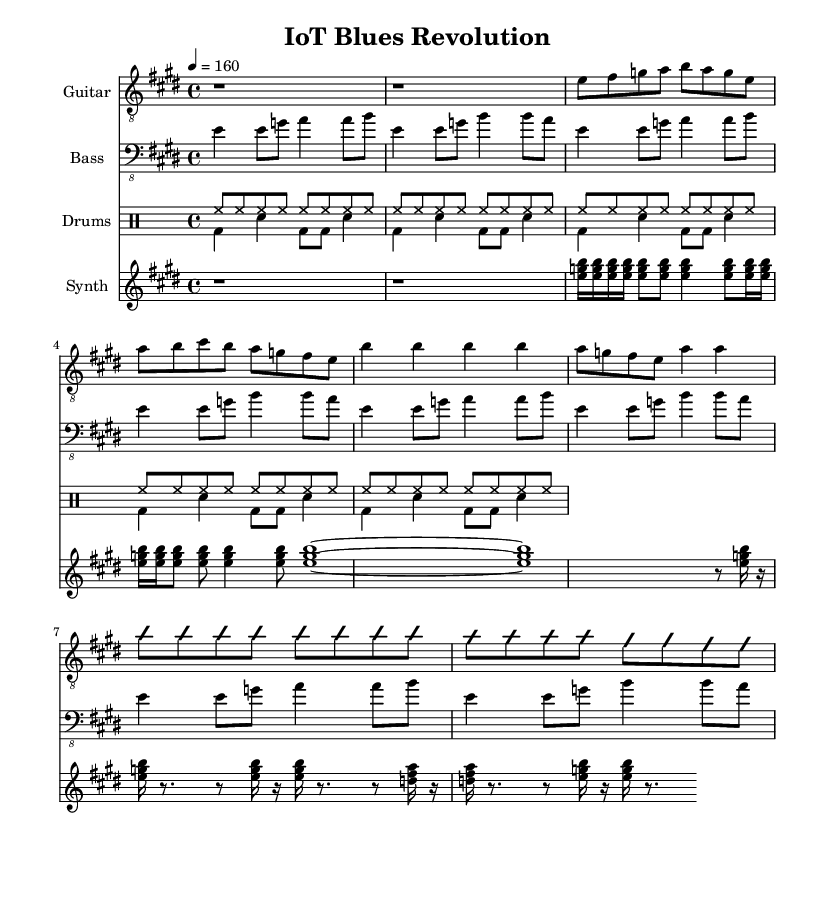What is the key signature of this music? The key signature is E major, indicated by the sharps (F# and C#) present in the sheet music.
Answer: E major What is the time signature of this music? The time signature is 4/4, which is shown at the beginning of the score, indicating four beats per measure.
Answer: 4/4 What is the tempo marking of this piece? The tempo is marked as 4 equals 160, which means there are 160 beats per minute. This marking sets the pace for the performance.
Answer: 160 How many bars are in the guitar solo? By analyzing the guitar section, there are a total of 4 bars during the guitar solo. This can be counted from the beginning of the solo to the end.
Answer: 4 What type of music is this, based on its elements? The music is classified as Electric Blues due to its high-energy guitar riff, blues structure, and incorporation of electronic synth elements.
Answer: Electric Blues Which instrument plays the arpeggiated pattern in the verse? The synthesizer plays the arpeggiated pattern in the verse as indicated in the corresponding staff under the synthesizer section of the score.
Answer: Synthesizer What rhythmic pattern is used in the drum part throughout the piece? The drums primarily use a consistent eighth-note pattern, shown by the repeated hi-hat notes combined with kick and snare in a typical rock style.
Answer: Eighth-note pattern 